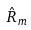<formula> <loc_0><loc_0><loc_500><loc_500>\hat { R } _ { m }</formula> 